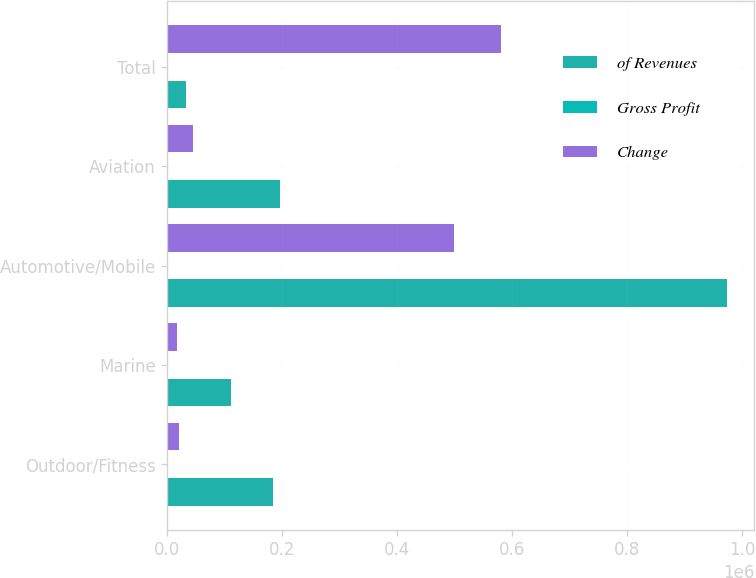<chart> <loc_0><loc_0><loc_500><loc_500><stacked_bar_chart><ecel><fcel>Outdoor/Fitness<fcel>Marine<fcel>Automotive/Mobile<fcel>Aviation<fcel>Total<nl><fcel>of Revenues<fcel>184655<fcel>110169<fcel>973205<fcel>195226<fcel>32819<nl><fcel>Gross Profit<fcel>54.4<fcel>54.2<fcel>41.6<fcel>66.2<fcel>46<nl><fcel>Change<fcel>21017<fcel>17217<fcel>498014<fcel>44621<fcel>580869<nl></chart> 